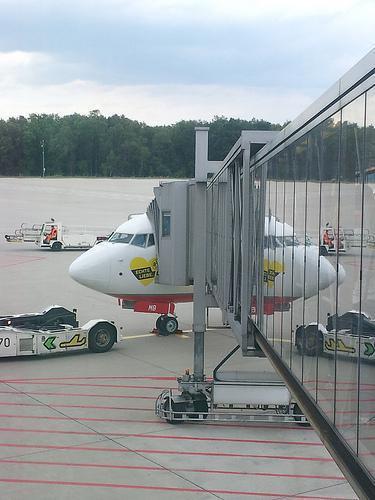How many airplanes are there?
Give a very brief answer. 1. How many pieces of luggage are visible on the runway?
Give a very brief answer. 0. 